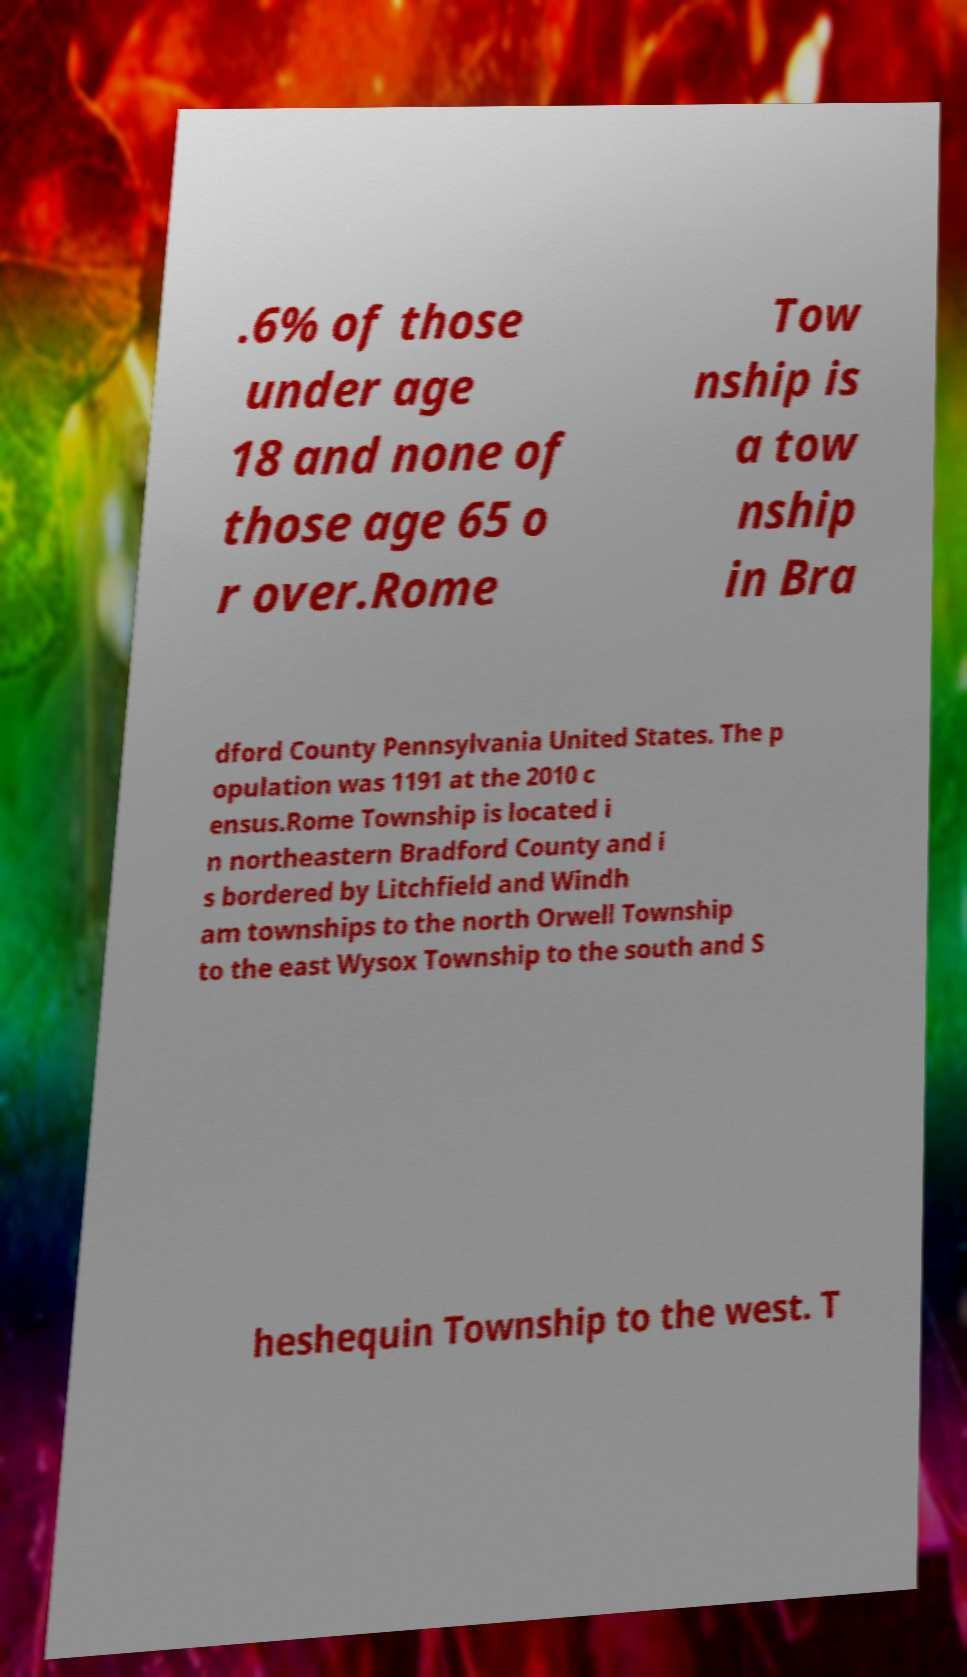Could you extract and type out the text from this image? .6% of those under age 18 and none of those age 65 o r over.Rome Tow nship is a tow nship in Bra dford County Pennsylvania United States. The p opulation was 1191 at the 2010 c ensus.Rome Township is located i n northeastern Bradford County and i s bordered by Litchfield and Windh am townships to the north Orwell Township to the east Wysox Township to the south and S heshequin Township to the west. T 